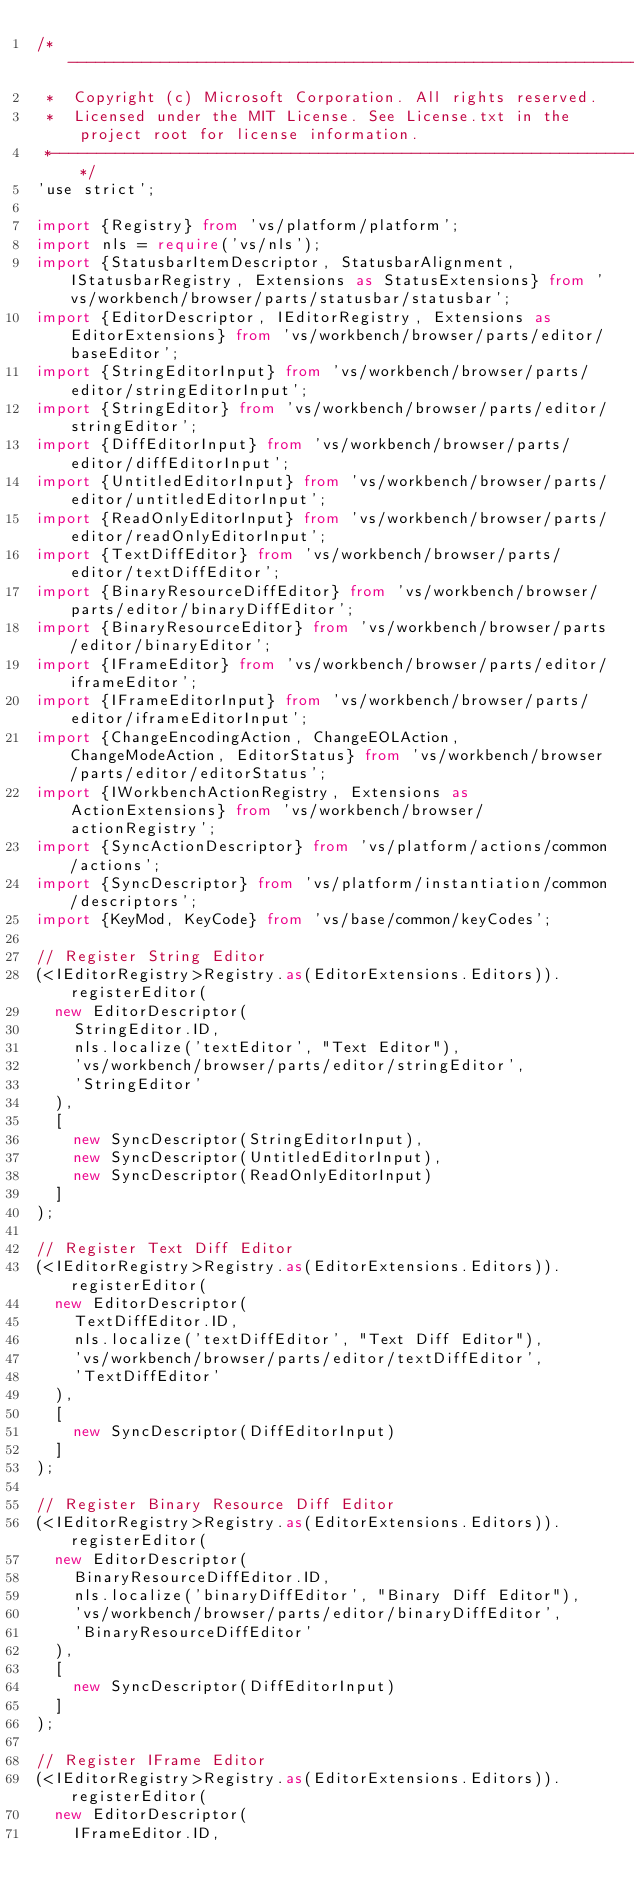Convert code to text. <code><loc_0><loc_0><loc_500><loc_500><_TypeScript_>/*---------------------------------------------------------------------------------------------
 *  Copyright (c) Microsoft Corporation. All rights reserved.
 *  Licensed under the MIT License. See License.txt in the project root for license information.
 *--------------------------------------------------------------------------------------------*/
'use strict';

import {Registry} from 'vs/platform/platform';
import nls = require('vs/nls');
import {StatusbarItemDescriptor, StatusbarAlignment, IStatusbarRegistry, Extensions as StatusExtensions} from 'vs/workbench/browser/parts/statusbar/statusbar';
import {EditorDescriptor, IEditorRegistry, Extensions as EditorExtensions} from 'vs/workbench/browser/parts/editor/baseEditor';
import {StringEditorInput} from 'vs/workbench/browser/parts/editor/stringEditorInput';
import {StringEditor} from 'vs/workbench/browser/parts/editor/stringEditor';
import {DiffEditorInput} from 'vs/workbench/browser/parts/editor/diffEditorInput';
import {UntitledEditorInput} from 'vs/workbench/browser/parts/editor/untitledEditorInput';
import {ReadOnlyEditorInput} from 'vs/workbench/browser/parts/editor/readOnlyEditorInput';
import {TextDiffEditor} from 'vs/workbench/browser/parts/editor/textDiffEditor';
import {BinaryResourceDiffEditor} from 'vs/workbench/browser/parts/editor/binaryDiffEditor';
import {BinaryResourceEditor} from 'vs/workbench/browser/parts/editor/binaryEditor';
import {IFrameEditor} from 'vs/workbench/browser/parts/editor/iframeEditor';
import {IFrameEditorInput} from 'vs/workbench/browser/parts/editor/iframeEditorInput';
import {ChangeEncodingAction, ChangeEOLAction, ChangeModeAction, EditorStatus} from 'vs/workbench/browser/parts/editor/editorStatus';
import {IWorkbenchActionRegistry, Extensions as ActionExtensions} from 'vs/workbench/browser/actionRegistry';
import {SyncActionDescriptor} from 'vs/platform/actions/common/actions';
import {SyncDescriptor} from 'vs/platform/instantiation/common/descriptors';
import {KeyMod, KeyCode} from 'vs/base/common/keyCodes';

// Register String Editor
(<IEditorRegistry>Registry.as(EditorExtensions.Editors)).registerEditor(
	new EditorDescriptor(
		StringEditor.ID,
		nls.localize('textEditor', "Text Editor"),
		'vs/workbench/browser/parts/editor/stringEditor',
		'StringEditor'
	),
	[
		new SyncDescriptor(StringEditorInput),
		new SyncDescriptor(UntitledEditorInput),
		new SyncDescriptor(ReadOnlyEditorInput)
	]
);

// Register Text Diff Editor
(<IEditorRegistry>Registry.as(EditorExtensions.Editors)).registerEditor(
	new EditorDescriptor(
		TextDiffEditor.ID,
		nls.localize('textDiffEditor', "Text Diff Editor"),
		'vs/workbench/browser/parts/editor/textDiffEditor',
		'TextDiffEditor'
	),
	[
		new SyncDescriptor(DiffEditorInput)
	]
);

// Register Binary Resource Diff Editor
(<IEditorRegistry>Registry.as(EditorExtensions.Editors)).registerEditor(
	new EditorDescriptor(
		BinaryResourceDiffEditor.ID,
		nls.localize('binaryDiffEditor', "Binary Diff Editor"),
		'vs/workbench/browser/parts/editor/binaryDiffEditor',
		'BinaryResourceDiffEditor'
	),
	[
		new SyncDescriptor(DiffEditorInput)
	]
);

// Register IFrame Editor
(<IEditorRegistry>Registry.as(EditorExtensions.Editors)).registerEditor(
	new EditorDescriptor(
		IFrameEditor.ID,</code> 